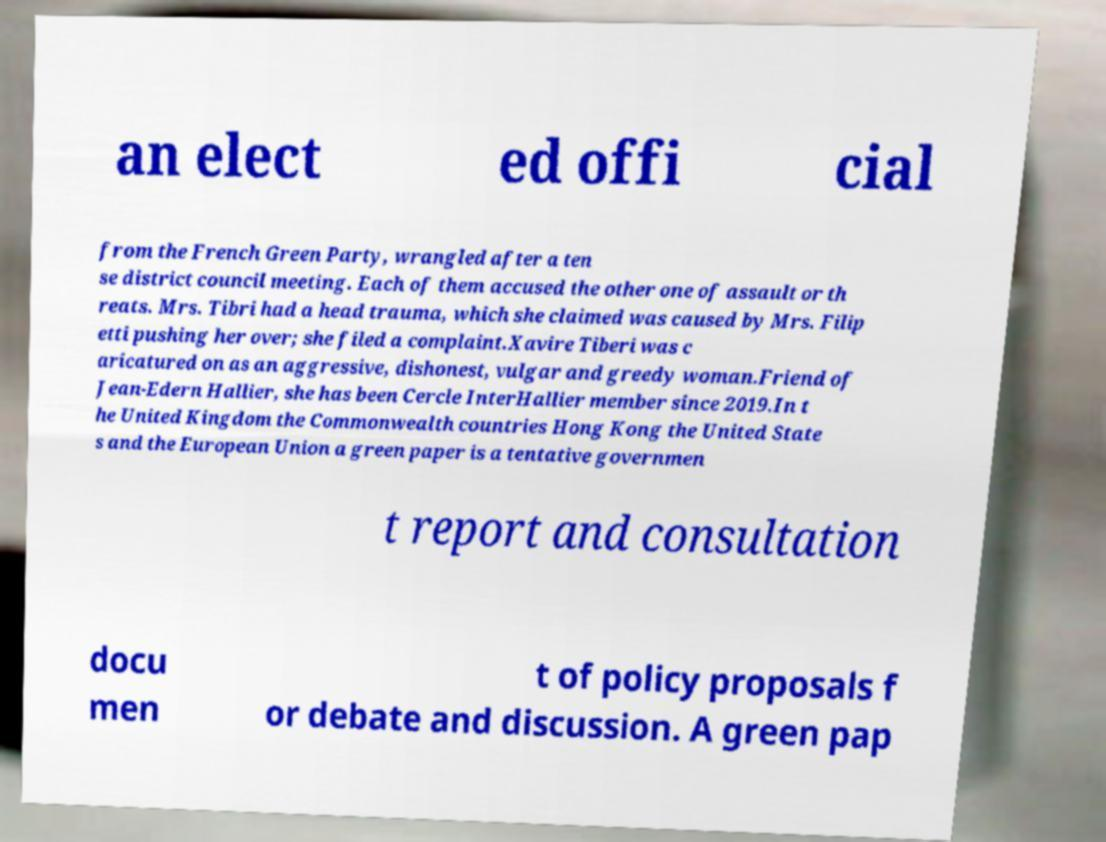Could you assist in decoding the text presented in this image and type it out clearly? an elect ed offi cial from the French Green Party, wrangled after a ten se district council meeting. Each of them accused the other one of assault or th reats. Mrs. Tibri had a head trauma, which she claimed was caused by Mrs. Filip etti pushing her over; she filed a complaint.Xavire Tiberi was c aricatured on as an aggressive, dishonest, vulgar and greedy woman.Friend of Jean-Edern Hallier, she has been Cercle InterHallier member since 2019.In t he United Kingdom the Commonwealth countries Hong Kong the United State s and the European Union a green paper is a tentative governmen t report and consultation docu men t of policy proposals f or debate and discussion. A green pap 